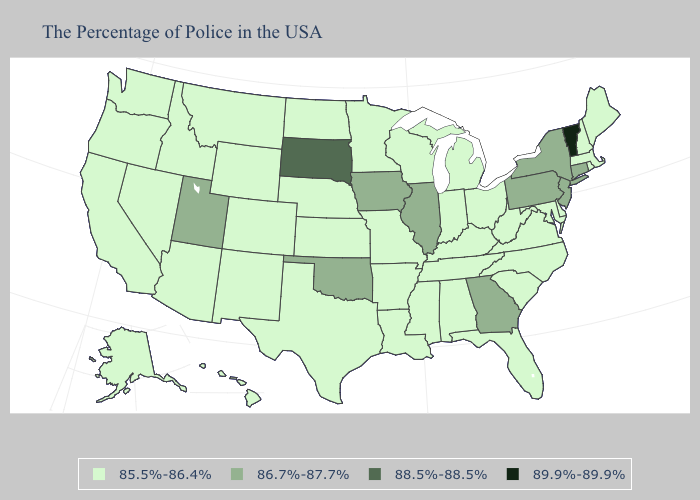Among the states that border Arkansas , which have the lowest value?
Concise answer only. Tennessee, Mississippi, Louisiana, Missouri, Texas. Name the states that have a value in the range 85.5%-86.4%?
Quick response, please. Maine, Massachusetts, Rhode Island, New Hampshire, Delaware, Maryland, Virginia, North Carolina, South Carolina, West Virginia, Ohio, Florida, Michigan, Kentucky, Indiana, Alabama, Tennessee, Wisconsin, Mississippi, Louisiana, Missouri, Arkansas, Minnesota, Kansas, Nebraska, Texas, North Dakota, Wyoming, Colorado, New Mexico, Montana, Arizona, Idaho, Nevada, California, Washington, Oregon, Alaska, Hawaii. What is the lowest value in states that border Missouri?
Answer briefly. 85.5%-86.4%. Among the states that border Florida , which have the lowest value?
Keep it brief. Alabama. Name the states that have a value in the range 85.5%-86.4%?
Keep it brief. Maine, Massachusetts, Rhode Island, New Hampshire, Delaware, Maryland, Virginia, North Carolina, South Carolina, West Virginia, Ohio, Florida, Michigan, Kentucky, Indiana, Alabama, Tennessee, Wisconsin, Mississippi, Louisiana, Missouri, Arkansas, Minnesota, Kansas, Nebraska, Texas, North Dakota, Wyoming, Colorado, New Mexico, Montana, Arizona, Idaho, Nevada, California, Washington, Oregon, Alaska, Hawaii. What is the highest value in states that border New York?
Quick response, please. 89.9%-89.9%. Name the states that have a value in the range 88.5%-88.5%?
Keep it brief. South Dakota. What is the lowest value in the MidWest?
Quick response, please. 85.5%-86.4%. Does New Jersey have the lowest value in the USA?
Keep it brief. No. Among the states that border Nebraska , which have the lowest value?
Be succinct. Missouri, Kansas, Wyoming, Colorado. Does Vermont have the lowest value in the Northeast?
Keep it brief. No. Name the states that have a value in the range 89.9%-89.9%?
Short answer required. Vermont. What is the highest value in the USA?
Quick response, please. 89.9%-89.9%. How many symbols are there in the legend?
Keep it brief. 4. What is the value of Mississippi?
Concise answer only. 85.5%-86.4%. 